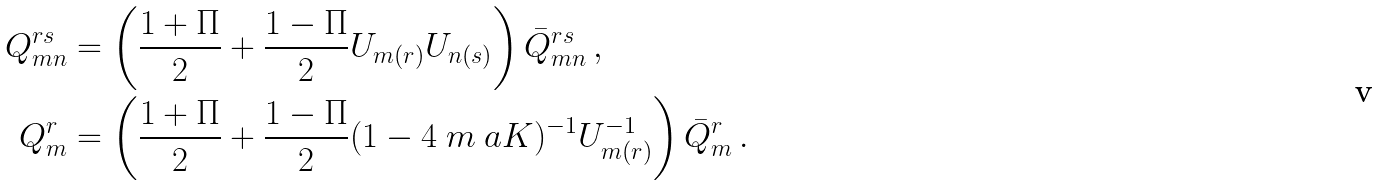Convert formula to latex. <formula><loc_0><loc_0><loc_500><loc_500>Q ^ { r s } _ { m n } & = \left ( \frac { 1 + \Pi } { 2 } + \frac { 1 - \Pi } { 2 } U _ { m ( r ) } U _ { n ( s ) } \right ) \bar { Q } ^ { r s } _ { m n } \, , \\ Q ^ { r } _ { m } & = \left ( \frac { 1 + \Pi } { 2 } + \frac { 1 - \Pi } { 2 } ( 1 - 4 \ m \ a K ) ^ { - 1 } U _ { m ( r ) } ^ { - 1 } \right ) \bar { Q } ^ { r } _ { m } \, .</formula> 